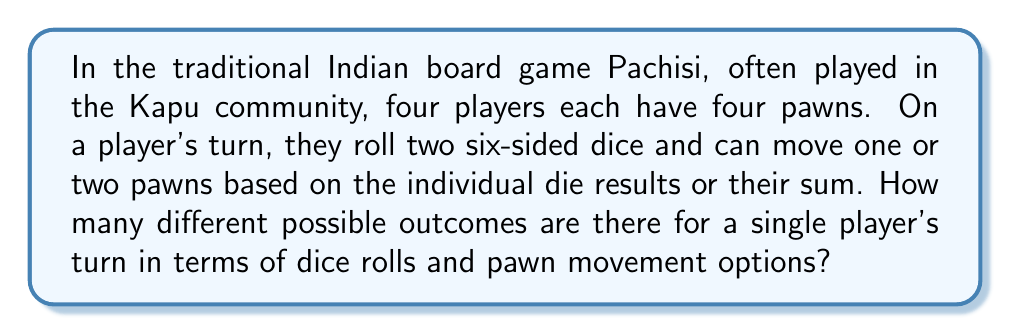What is the answer to this math problem? Let's break this down step-by-step:

1) First, we need to calculate the number of possible dice roll outcomes:
   There are 6 possible outcomes for each die, so there are $6 \times 6 = 36$ possible dice roll combinations.

2) For each dice roll, the player has the following options:
   a) Move one pawn based on the first die result
   b) Move one pawn based on the second die result
   c) Move one pawn based on the sum of both dice
   d) Move two pawns, each based on one of the die results

3) The player has 4 pawns to choose from for each of these moves. Let's calculate the number of options for each case:
   a) $4$ ways to choose a pawn for the first die
   b) $4$ ways to choose a pawn for the second die
   c) $4$ ways to choose a pawn for the sum
   d) $4 \times 3 = 12$ ways to choose two different pawns (order matters)

4) The total number of pawn movement options for each dice roll is thus:
   $4 + 4 + 4 + 12 = 24$

5) Therefore, the total number of possible outcomes is:
   $$ 36 \times 24 = 864 $$

This accounts for all possible dice roll combinations and all possible pawn movement options for each roll.
Answer: 864 